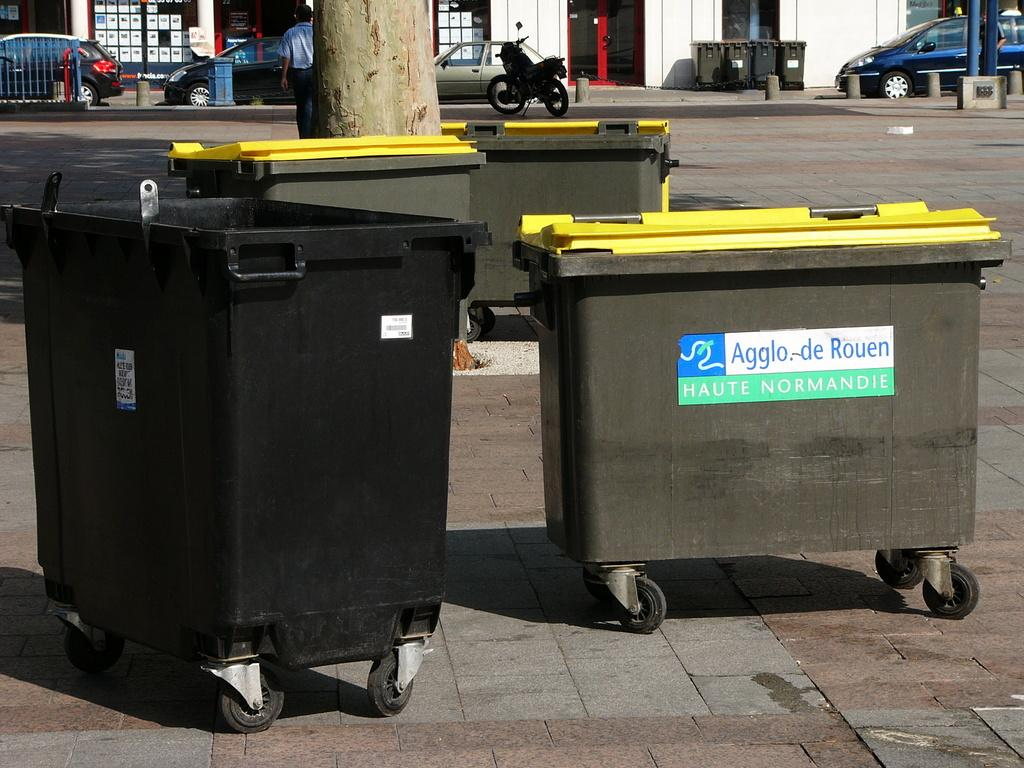<image>
Summarize the visual content of the image. The dumpster near a street has Aggle. de Rouen Haute Normandie on it. 